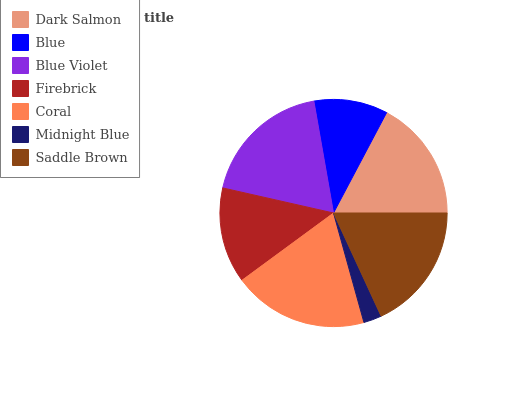Is Midnight Blue the minimum?
Answer yes or no. Yes. Is Coral the maximum?
Answer yes or no. Yes. Is Blue the minimum?
Answer yes or no. No. Is Blue the maximum?
Answer yes or no. No. Is Dark Salmon greater than Blue?
Answer yes or no. Yes. Is Blue less than Dark Salmon?
Answer yes or no. Yes. Is Blue greater than Dark Salmon?
Answer yes or no. No. Is Dark Salmon less than Blue?
Answer yes or no. No. Is Dark Salmon the high median?
Answer yes or no. Yes. Is Dark Salmon the low median?
Answer yes or no. Yes. Is Firebrick the high median?
Answer yes or no. No. Is Blue the low median?
Answer yes or no. No. 